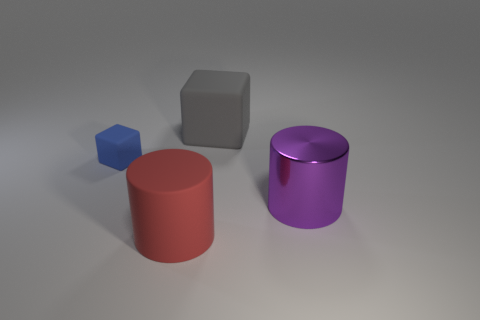Does the purple cylinder have the same size as the blue object?
Give a very brief answer. No. Is there any other thing that has the same material as the large purple object?
Provide a short and direct response. No. There is a big red thing; is it the same shape as the thing to the right of the large gray object?
Your answer should be very brief. Yes. How many things are to the left of the purple object and in front of the gray matte thing?
Your answer should be very brief. 2. The block right of the cube that is in front of the cube right of the blue matte object is made of what material?
Offer a terse response. Rubber. What shape is the gray thing that is the same size as the purple metallic thing?
Provide a succinct answer. Cube. There is a big matte thing that is in front of the purple object; does it have the same shape as the big thing that is behind the large purple metallic thing?
Keep it short and to the point. No. Is there a brown cylinder of the same size as the metallic thing?
Offer a very short reply. No. Is the number of large gray blocks that are in front of the big matte cylinder the same as the number of large red objects that are to the right of the big purple metallic object?
Offer a very short reply. Yes. Is the material of the object to the left of the red rubber cylinder the same as the cube on the right side of the big red matte object?
Your response must be concise. Yes. 